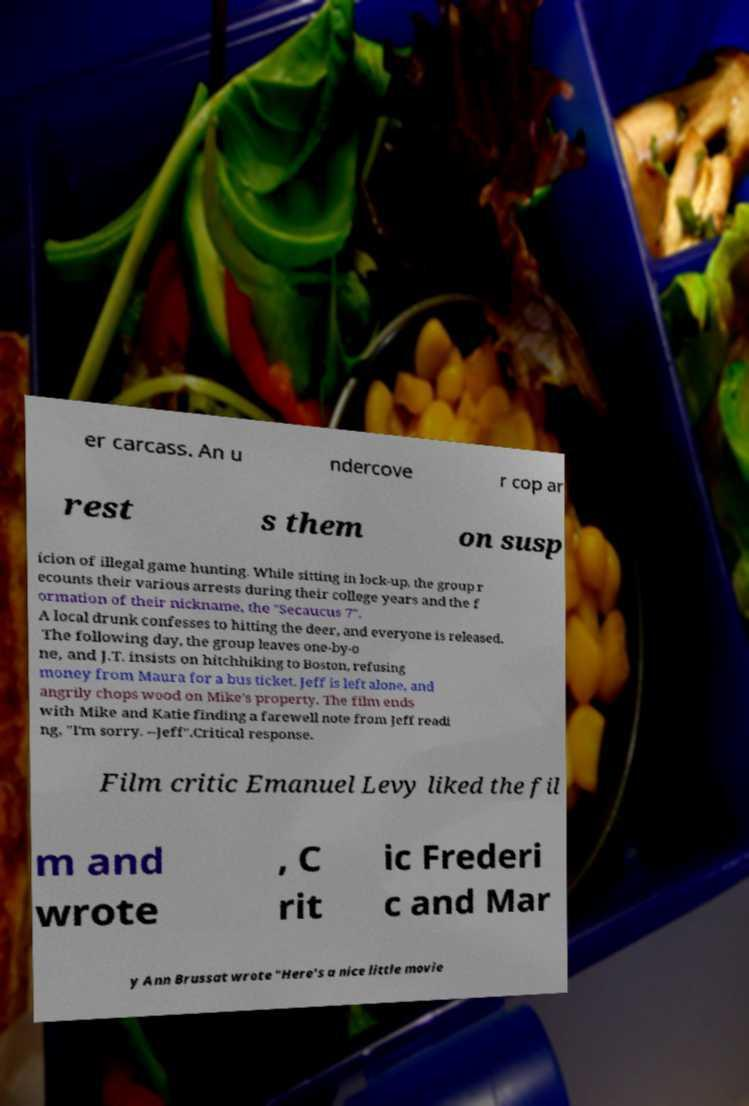Please read and relay the text visible in this image. What does it say? er carcass. An u ndercove r cop ar rest s them on susp icion of illegal game hunting. While sitting in lock-up, the group r ecounts their various arrests during their college years and the f ormation of their nickname, the "Secaucus 7". A local drunk confesses to hitting the deer, and everyone is released. The following day, the group leaves one-by-o ne, and J.T. insists on hitchhiking to Boston, refusing money from Maura for a bus ticket. Jeff is left alone, and angrily chops wood on Mike's property. The film ends with Mike and Katie finding a farewell note from Jeff readi ng, "I'm sorry. --Jeff".Critical response. Film critic Emanuel Levy liked the fil m and wrote , C rit ic Frederi c and Mar y Ann Brussat wrote "Here's a nice little movie 